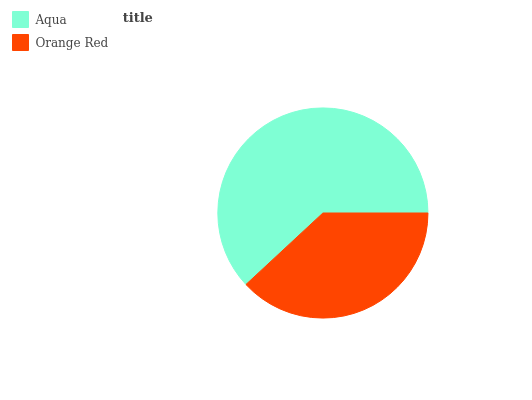Is Orange Red the minimum?
Answer yes or no. Yes. Is Aqua the maximum?
Answer yes or no. Yes. Is Orange Red the maximum?
Answer yes or no. No. Is Aqua greater than Orange Red?
Answer yes or no. Yes. Is Orange Red less than Aqua?
Answer yes or no. Yes. Is Orange Red greater than Aqua?
Answer yes or no. No. Is Aqua less than Orange Red?
Answer yes or no. No. Is Aqua the high median?
Answer yes or no. Yes. Is Orange Red the low median?
Answer yes or no. Yes. Is Orange Red the high median?
Answer yes or no. No. Is Aqua the low median?
Answer yes or no. No. 